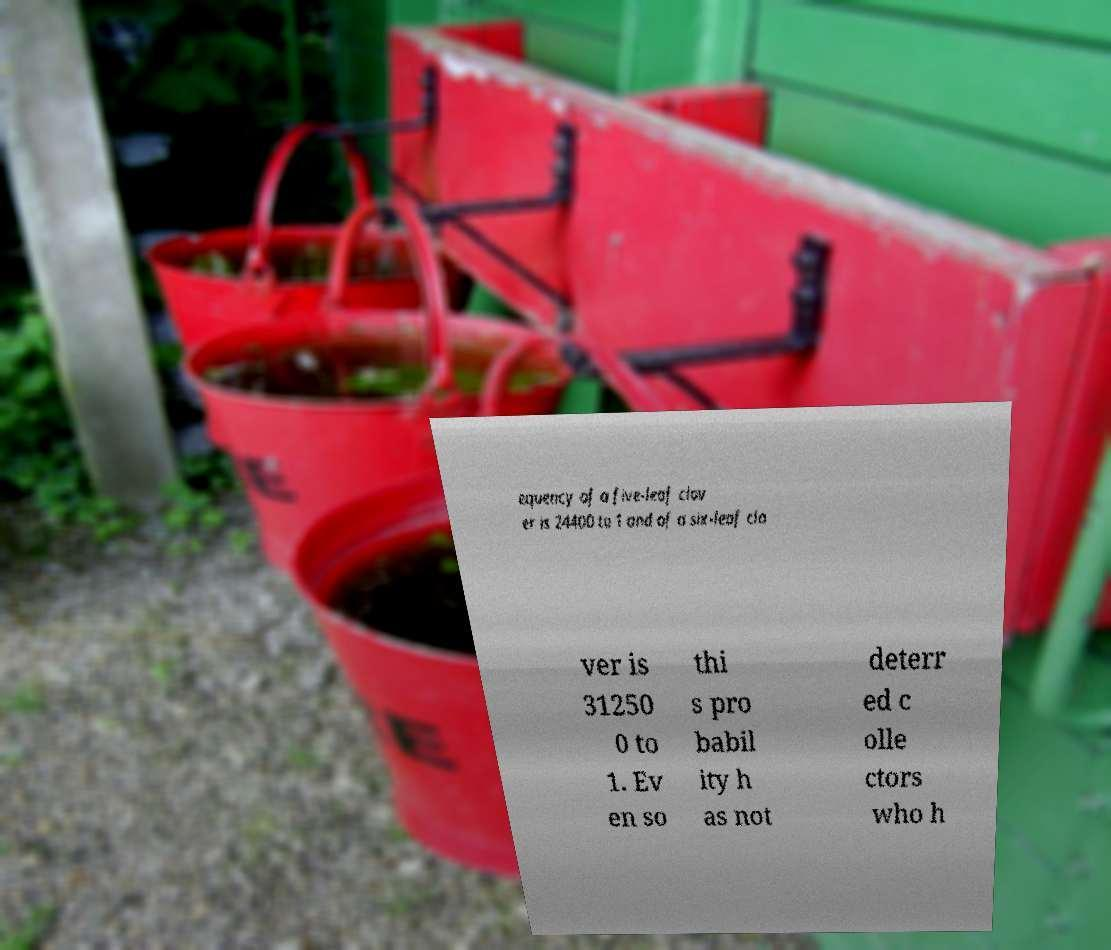Could you assist in decoding the text presented in this image and type it out clearly? equency of a five-leaf clov er is 24400 to 1 and of a six-leaf clo ver is 31250 0 to 1. Ev en so thi s pro babil ity h as not deterr ed c olle ctors who h 